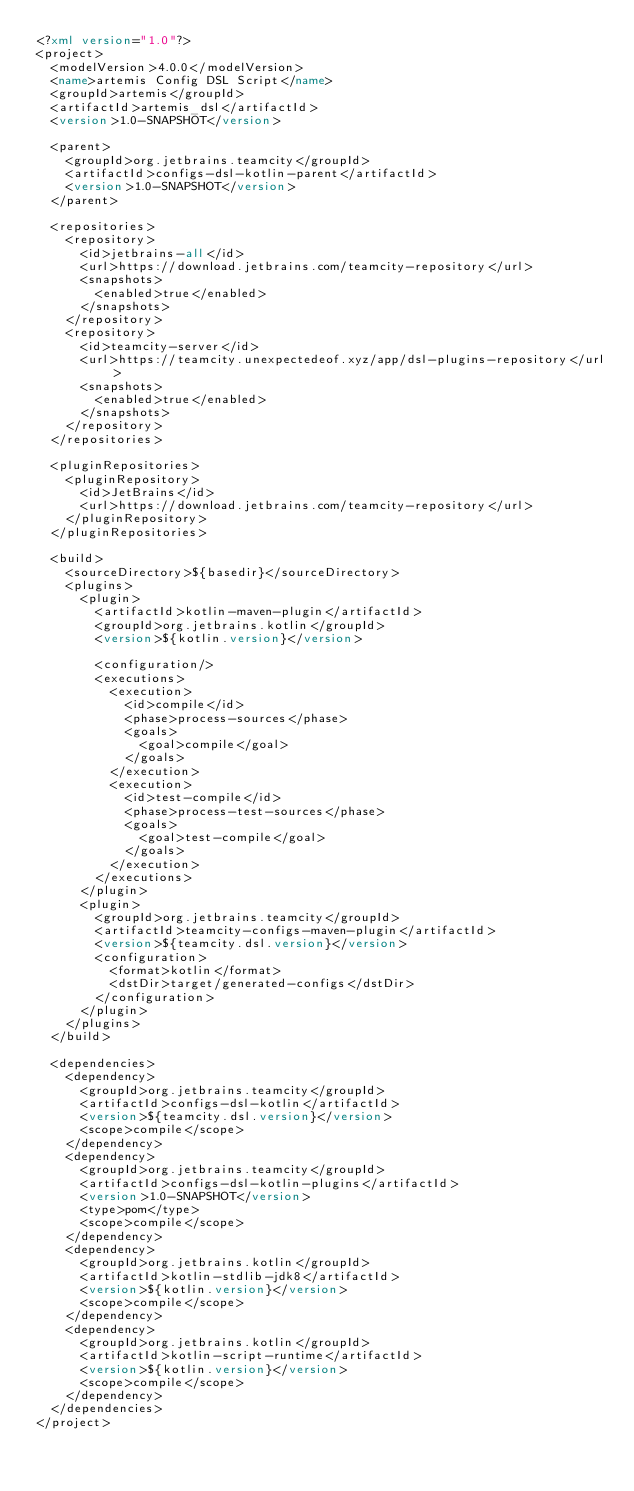Convert code to text. <code><loc_0><loc_0><loc_500><loc_500><_XML_><?xml version="1.0"?>
<project>
  <modelVersion>4.0.0</modelVersion>
  <name>artemis Config DSL Script</name>
  <groupId>artemis</groupId>
  <artifactId>artemis_dsl</artifactId>
  <version>1.0-SNAPSHOT</version>

  <parent>
    <groupId>org.jetbrains.teamcity</groupId>
    <artifactId>configs-dsl-kotlin-parent</artifactId>
    <version>1.0-SNAPSHOT</version>
  </parent>

  <repositories>
    <repository>
      <id>jetbrains-all</id>
      <url>https://download.jetbrains.com/teamcity-repository</url>
      <snapshots>
        <enabled>true</enabled>
      </snapshots>
    </repository>
    <repository>
      <id>teamcity-server</id>
      <url>https://teamcity.unexpectedeof.xyz/app/dsl-plugins-repository</url>
      <snapshots>
        <enabled>true</enabled>
      </snapshots>
    </repository>
  </repositories>

  <pluginRepositories>
    <pluginRepository>
      <id>JetBrains</id>
      <url>https://download.jetbrains.com/teamcity-repository</url>
    </pluginRepository>
  </pluginRepositories>

  <build>
    <sourceDirectory>${basedir}</sourceDirectory>
    <plugins>
      <plugin>
        <artifactId>kotlin-maven-plugin</artifactId>
        <groupId>org.jetbrains.kotlin</groupId>
        <version>${kotlin.version}</version>

        <configuration/>
        <executions>
          <execution>
            <id>compile</id>
            <phase>process-sources</phase>
            <goals>
              <goal>compile</goal>
            </goals>
          </execution>
          <execution>
            <id>test-compile</id>
            <phase>process-test-sources</phase>
            <goals>
              <goal>test-compile</goal>
            </goals>
          </execution>
        </executions>
      </plugin>
      <plugin>
        <groupId>org.jetbrains.teamcity</groupId>
        <artifactId>teamcity-configs-maven-plugin</artifactId>
        <version>${teamcity.dsl.version}</version>
        <configuration>
          <format>kotlin</format>
          <dstDir>target/generated-configs</dstDir>
        </configuration>
      </plugin>
    </plugins>
  </build>

  <dependencies>
    <dependency>
      <groupId>org.jetbrains.teamcity</groupId>
      <artifactId>configs-dsl-kotlin</artifactId>
      <version>${teamcity.dsl.version}</version>
      <scope>compile</scope>
    </dependency>
    <dependency>
      <groupId>org.jetbrains.teamcity</groupId>
      <artifactId>configs-dsl-kotlin-plugins</artifactId>
      <version>1.0-SNAPSHOT</version>
      <type>pom</type>
      <scope>compile</scope>
    </dependency>
    <dependency>
      <groupId>org.jetbrains.kotlin</groupId>
      <artifactId>kotlin-stdlib-jdk8</artifactId>
      <version>${kotlin.version}</version>
      <scope>compile</scope>
    </dependency>
    <dependency>
      <groupId>org.jetbrains.kotlin</groupId>
      <artifactId>kotlin-script-runtime</artifactId>
      <version>${kotlin.version}</version>
      <scope>compile</scope>
    </dependency>
  </dependencies>
</project></code> 